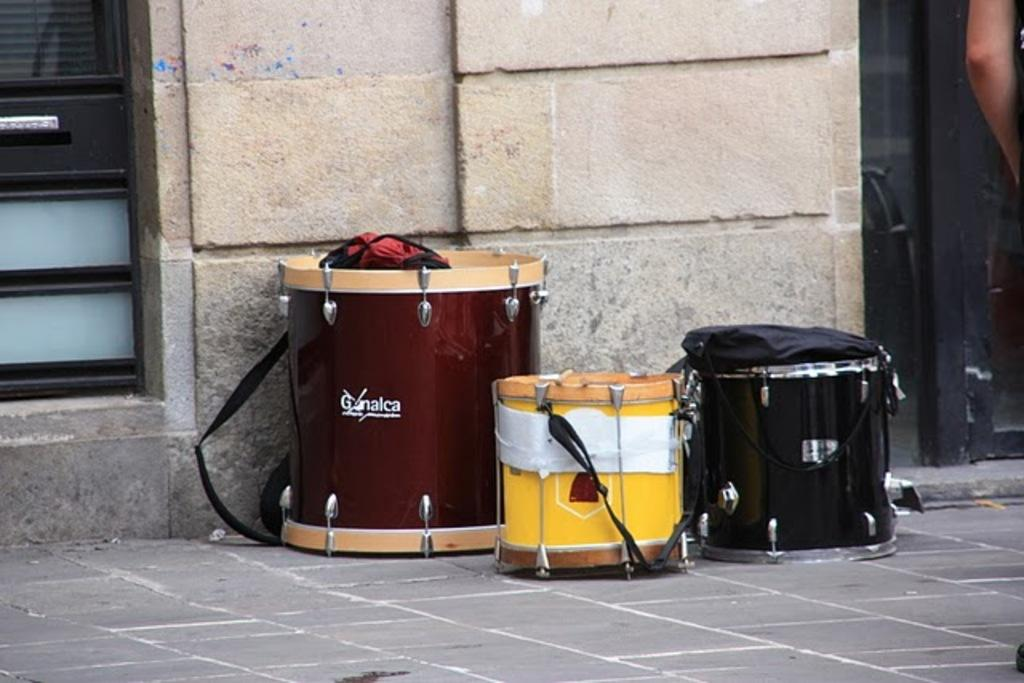<image>
Render a clear and concise summary of the photo. Three drums on the street one branded Ganalca. 